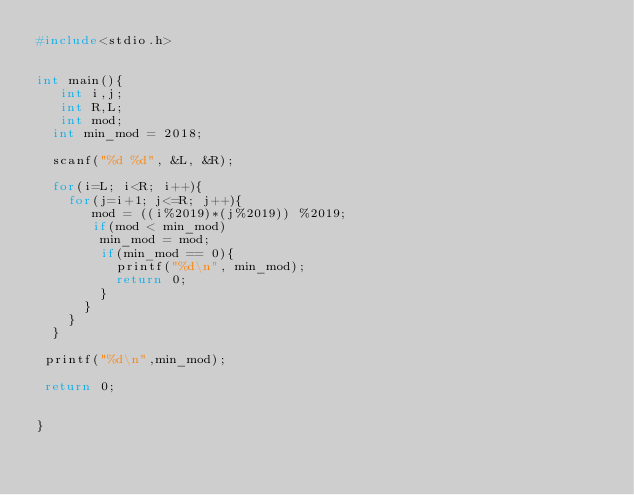Convert code to text. <code><loc_0><loc_0><loc_500><loc_500><_C_>#include<stdio.h>


int main(){
   int i,j;
   int R,L;
   int mod;
  int min_mod = 2018;

  scanf("%d %d", &L, &R);
   
  for(i=L; i<R; i++){
    for(j=i+1; j<=R; j++){
       mod = ((i%2019)*(j%2019)) %2019;
       if(mod < min_mod)
        min_mod = mod;
        if(min_mod == 0){
          printf("%d\n", min_mod);
          return 0;
        }
      }
    }
  }

 printf("%d\n",min_mod);

 return 0;
 
   
}</code> 